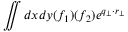<formula> <loc_0><loc_0><loc_500><loc_500>\iint d x d y ( f _ { 1 } ) ( f _ { 2 } ) e ^ { q _ { \perp } \cdot r _ { \perp } }</formula> 